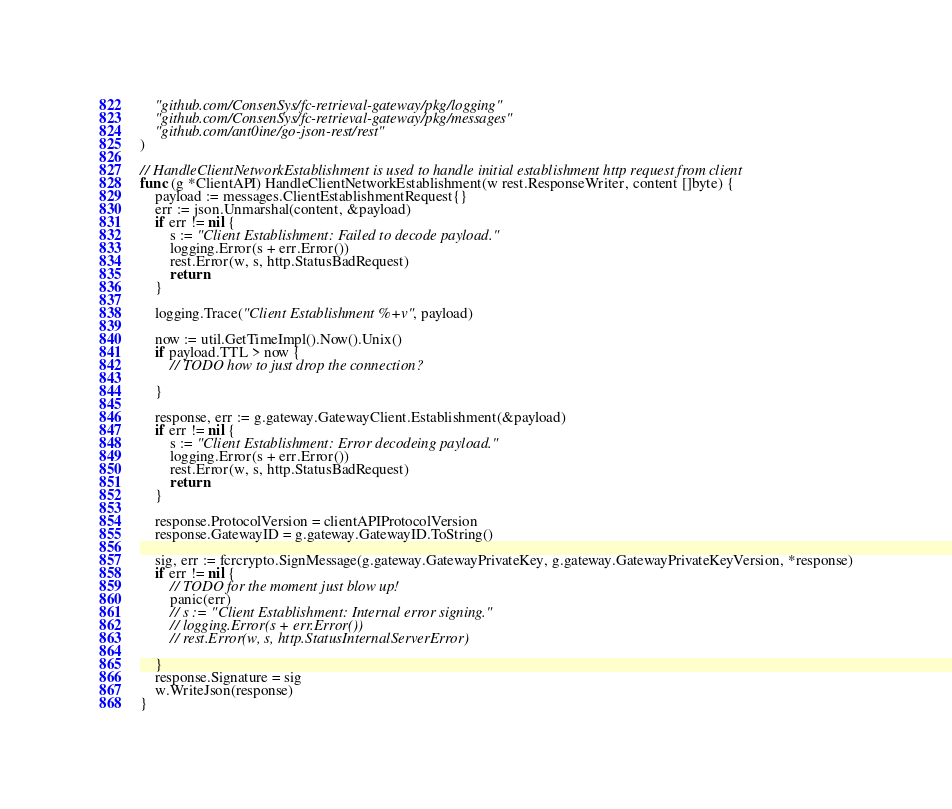Convert code to text. <code><loc_0><loc_0><loc_500><loc_500><_Go_>	"github.com/ConsenSys/fc-retrieval-gateway/pkg/logging"
	"github.com/ConsenSys/fc-retrieval-gateway/pkg/messages"
	"github.com/ant0ine/go-json-rest/rest"
)

// HandleClientNetworkEstablishment is used to handle initial establishment http request from client
func (g *ClientAPI) HandleClientNetworkEstablishment(w rest.ResponseWriter, content []byte) {
	payload := messages.ClientEstablishmentRequest{}
	err := json.Unmarshal(content, &payload)
	if err != nil {
		s := "Client Establishment: Failed to decode payload."
		logging.Error(s + err.Error())
		rest.Error(w, s, http.StatusBadRequest)
		return
	}

	logging.Trace("Client Establishment %+v", payload)

	now := util.GetTimeImpl().Now().Unix()
	if payload.TTL > now {
		// TODO how to just drop the connection?

	}

	response, err := g.gateway.GatewayClient.Establishment(&payload)
	if err != nil {
		s := "Client Establishment: Error decodeing payload."
		logging.Error(s + err.Error())
		rest.Error(w, s, http.StatusBadRequest)
		return
	}

	response.ProtocolVersion = clientAPIProtocolVersion
	response.GatewayID = g.gateway.GatewayID.ToString()

	sig, err := fcrcrypto.SignMessage(g.gateway.GatewayPrivateKey, g.gateway.GatewayPrivateKeyVersion, *response)
	if err != nil {
		// TODO for the moment just blow up!
		panic(err)
		// s := "Client Establishment: Internal error signing."
		// logging.Error(s + err.Error())
		// rest.Error(w, s, http.StatusInternalServerError)

	}
	response.Signature = sig
	w.WriteJson(response)
}
</code> 